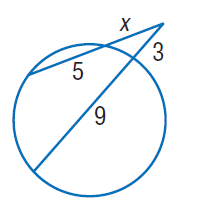Answer the mathemtical geometry problem and directly provide the correct option letter.
Question: Find x. Round to the nearest tenth if necessary. Assume that segments that appear to be tangent are tangent.
Choices: A: 3 B: 4 C: 5 D: 9 B 